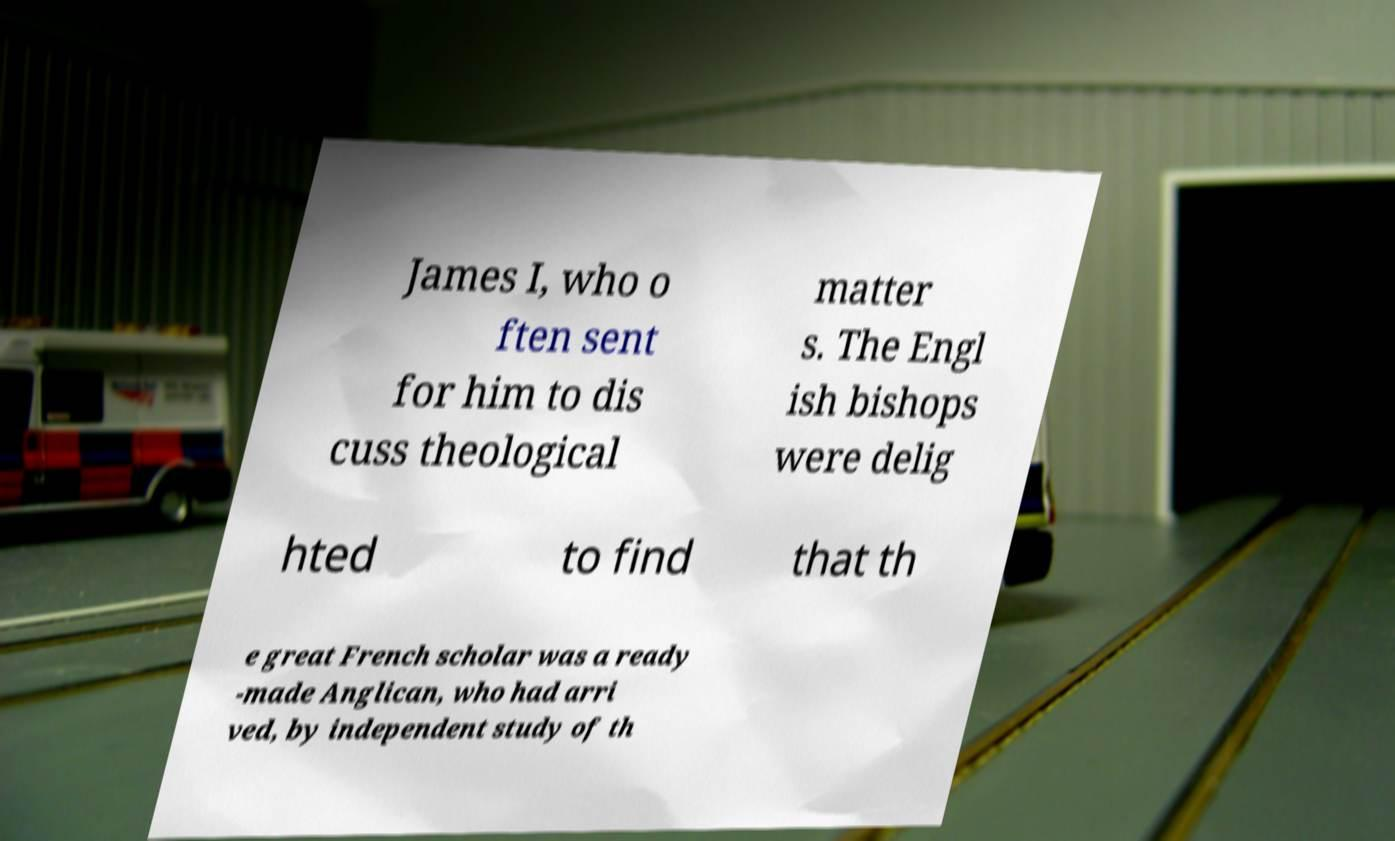Could you assist in decoding the text presented in this image and type it out clearly? James I, who o ften sent for him to dis cuss theological matter s. The Engl ish bishops were delig hted to find that th e great French scholar was a ready -made Anglican, who had arri ved, by independent study of th 